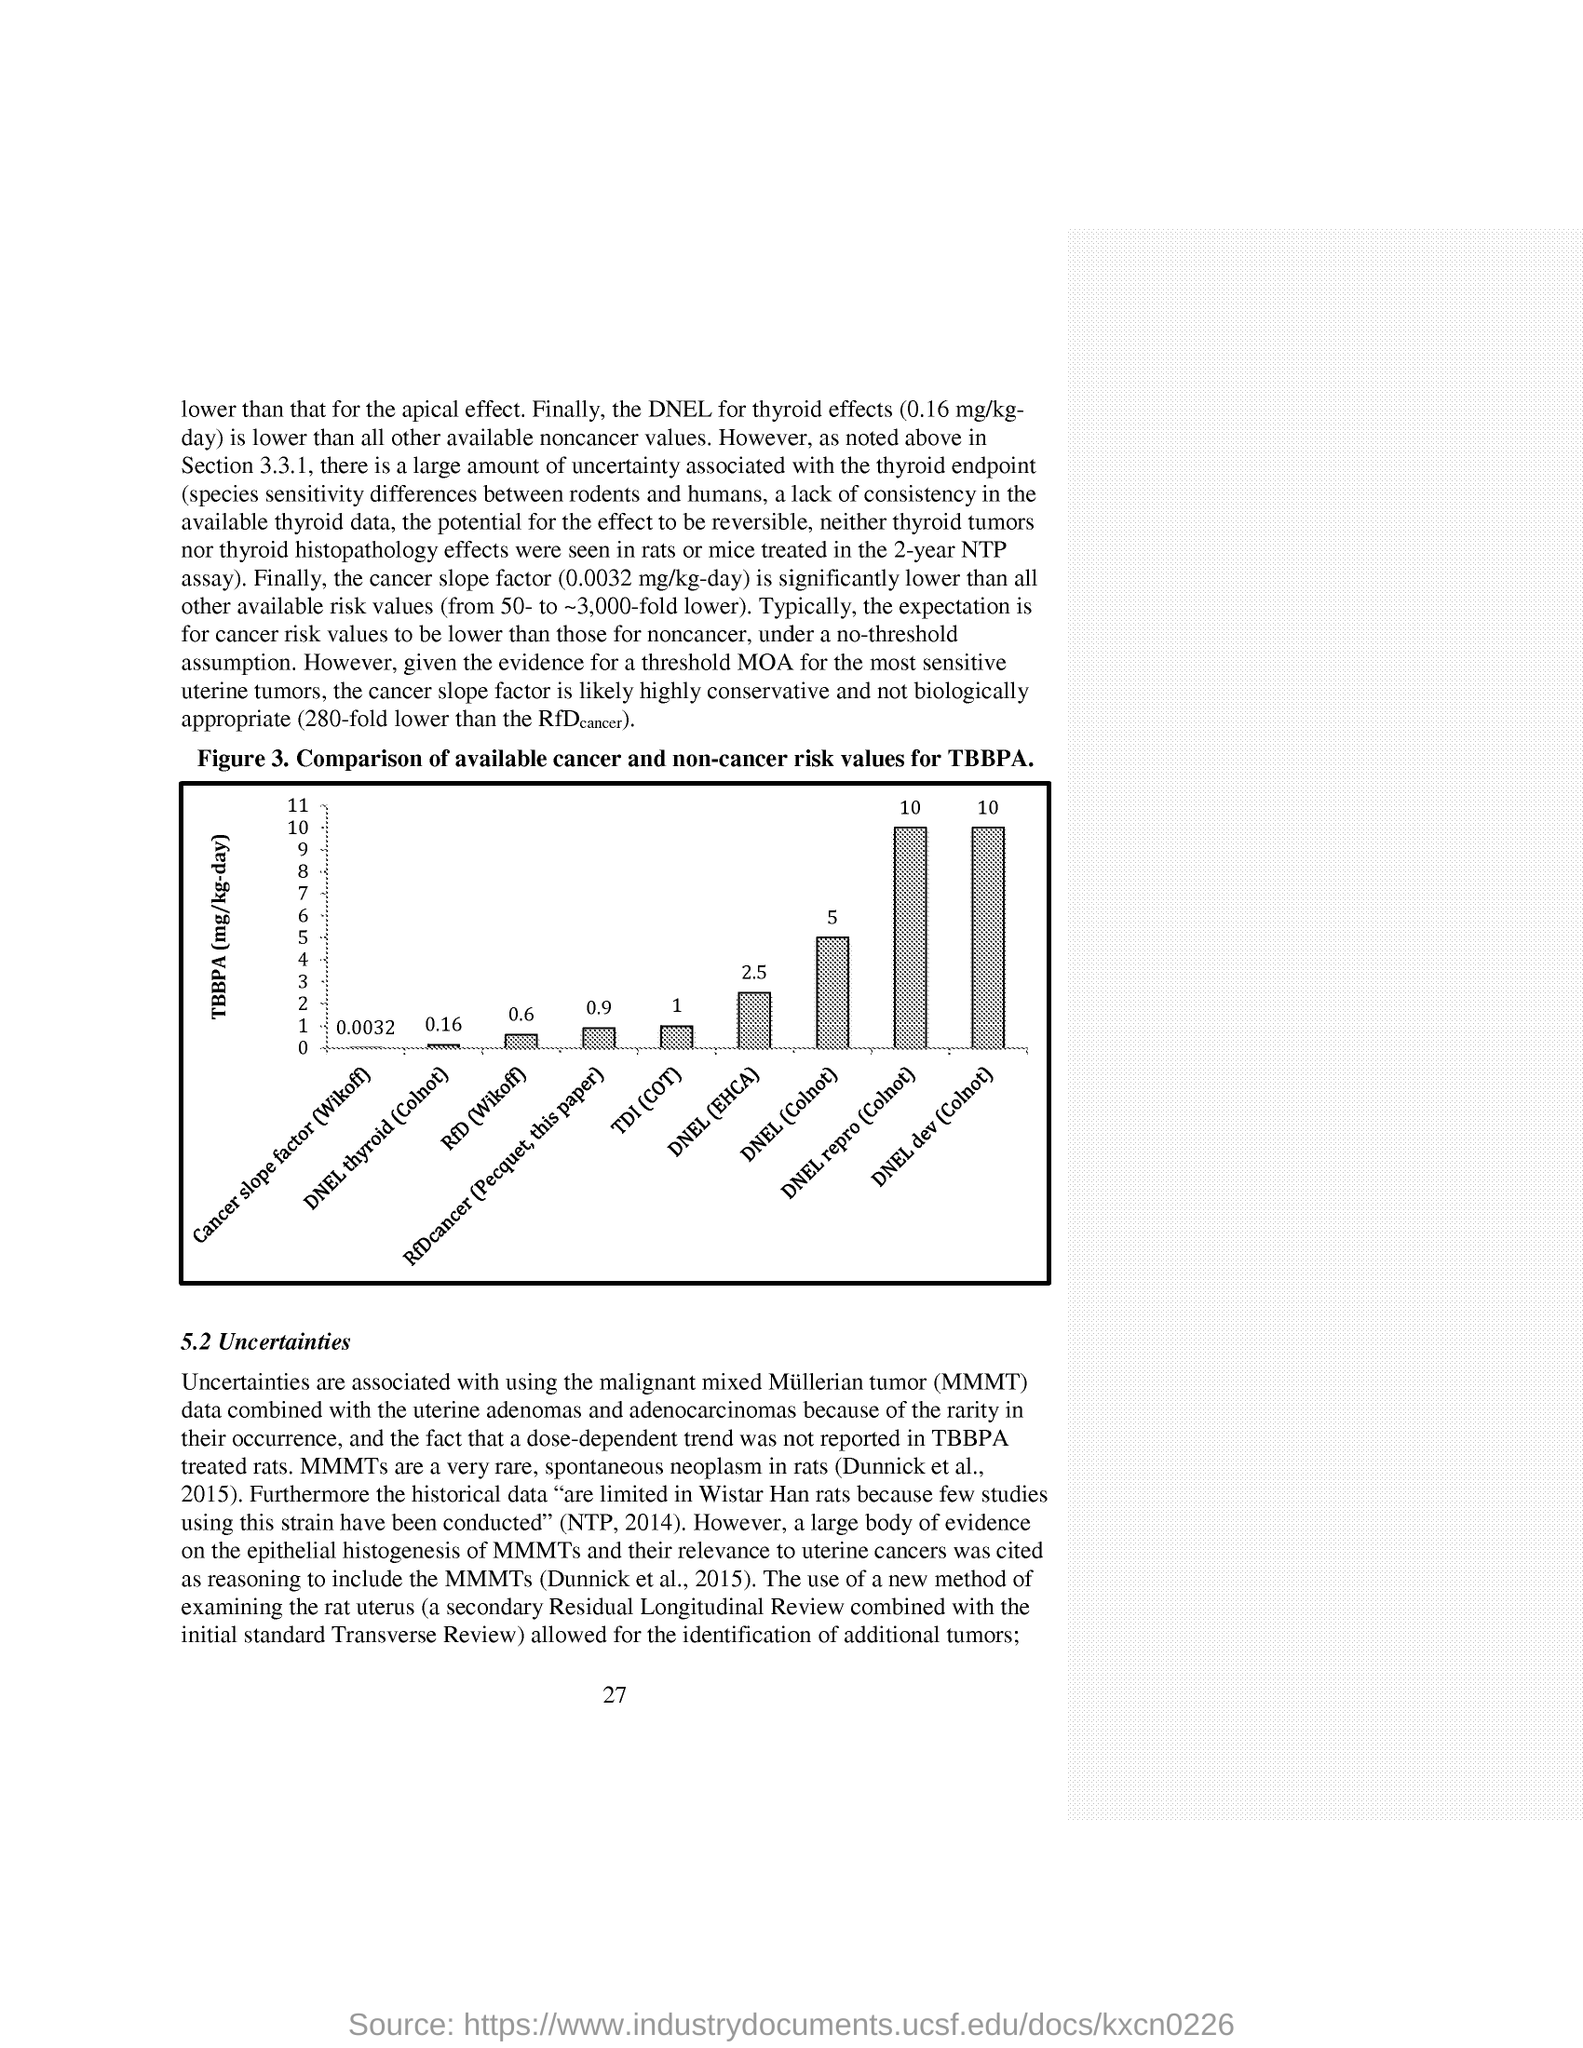The TBBPA is measured in terms of?
Make the answer very short. (mg/kg-day). How is the cancer slope factor defined?
Keep it short and to the point. The cancer slope factor (0.0032 mg/kg-day) is significantly lower than all other available risk values (from 50- to ~3,000-fold lower). What is the percentage of DNEL dev(Colnot) in the flowchart?
Give a very brief answer. 10. 